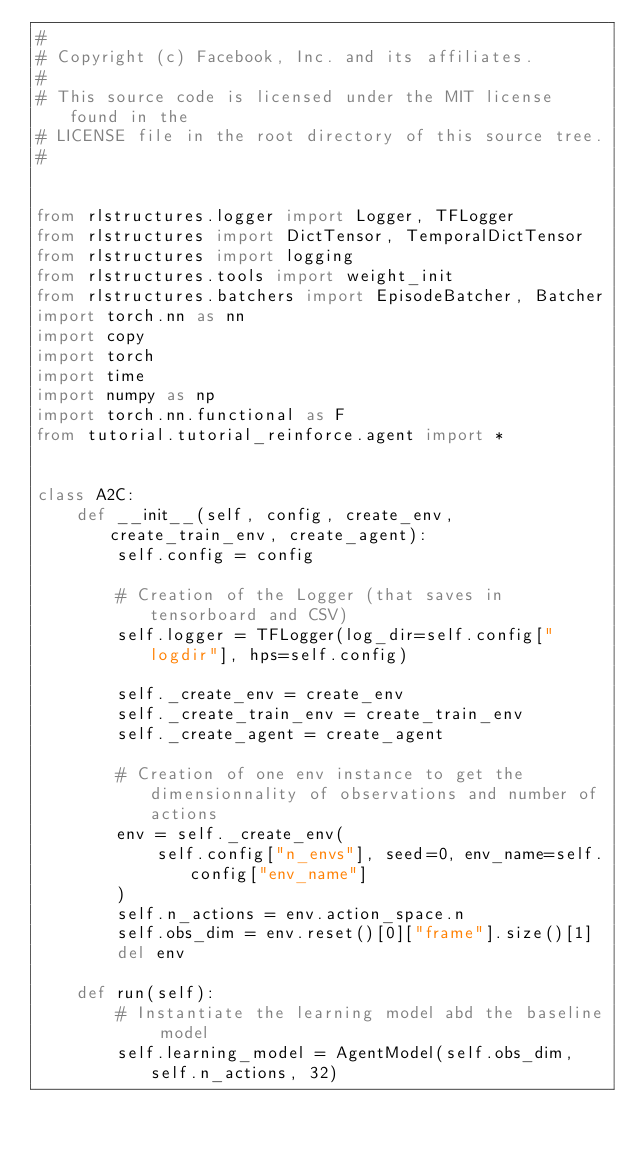<code> <loc_0><loc_0><loc_500><loc_500><_Python_>#
# Copyright (c) Facebook, Inc. and its affiliates.
#
# This source code is licensed under the MIT license found in the
# LICENSE file in the root directory of this source tree.
#


from rlstructures.logger import Logger, TFLogger
from rlstructures import DictTensor, TemporalDictTensor
from rlstructures import logging
from rlstructures.tools import weight_init
from rlstructures.batchers import EpisodeBatcher, Batcher
import torch.nn as nn
import copy
import torch
import time
import numpy as np
import torch.nn.functional as F
from tutorial.tutorial_reinforce.agent import *


class A2C:
    def __init__(self, config, create_env, create_train_env, create_agent):
        self.config = config

        # Creation of the Logger (that saves in tensorboard and CSV)
        self.logger = TFLogger(log_dir=self.config["logdir"], hps=self.config)

        self._create_env = create_env
        self._create_train_env = create_train_env
        self._create_agent = create_agent

        # Creation of one env instance to get the dimensionnality of observations and number of actions
        env = self._create_env(
            self.config["n_envs"], seed=0, env_name=self.config["env_name"]
        )
        self.n_actions = env.action_space.n
        self.obs_dim = env.reset()[0]["frame"].size()[1]
        del env

    def run(self):
        # Instantiate the learning model abd the baseline model
        self.learning_model = AgentModel(self.obs_dim, self.n_actions, 32)</code> 